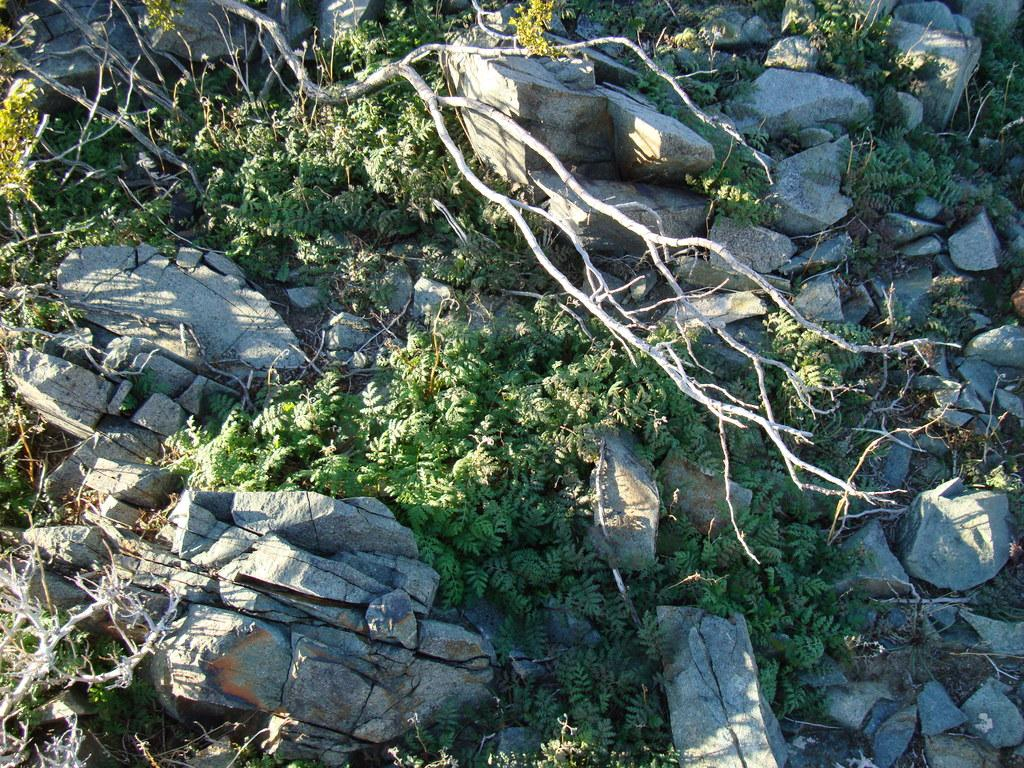What type of natural elements can be seen in the image? There are rocks and a few trees in the image. Can you describe the landscape in the image? The landscape in the image includes rocks and trees. What type of relation is being celebrated in the image? There is no indication of a relation being celebrated in the image, as it only features rocks and trees. How many eggs are visible in the image? There are no eggs present in the image; it only features rocks and trees. 